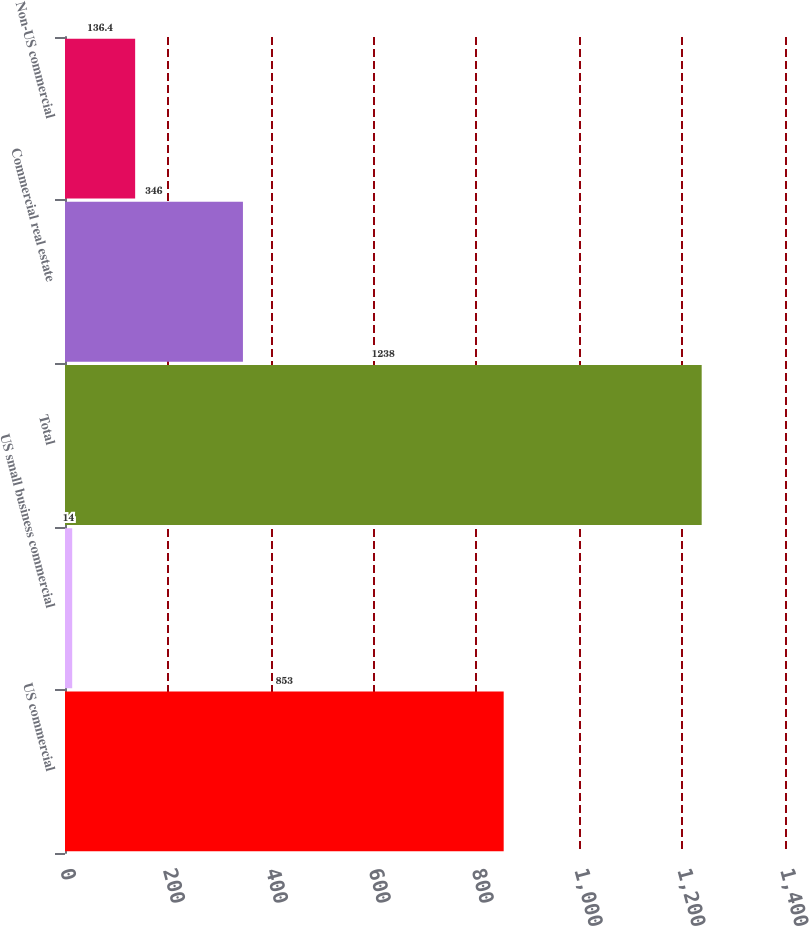Convert chart. <chart><loc_0><loc_0><loc_500><loc_500><bar_chart><fcel>US commercial<fcel>US small business commercial<fcel>Total<fcel>Commercial real estate<fcel>Non-US commercial<nl><fcel>853<fcel>14<fcel>1238<fcel>346<fcel>136.4<nl></chart> 